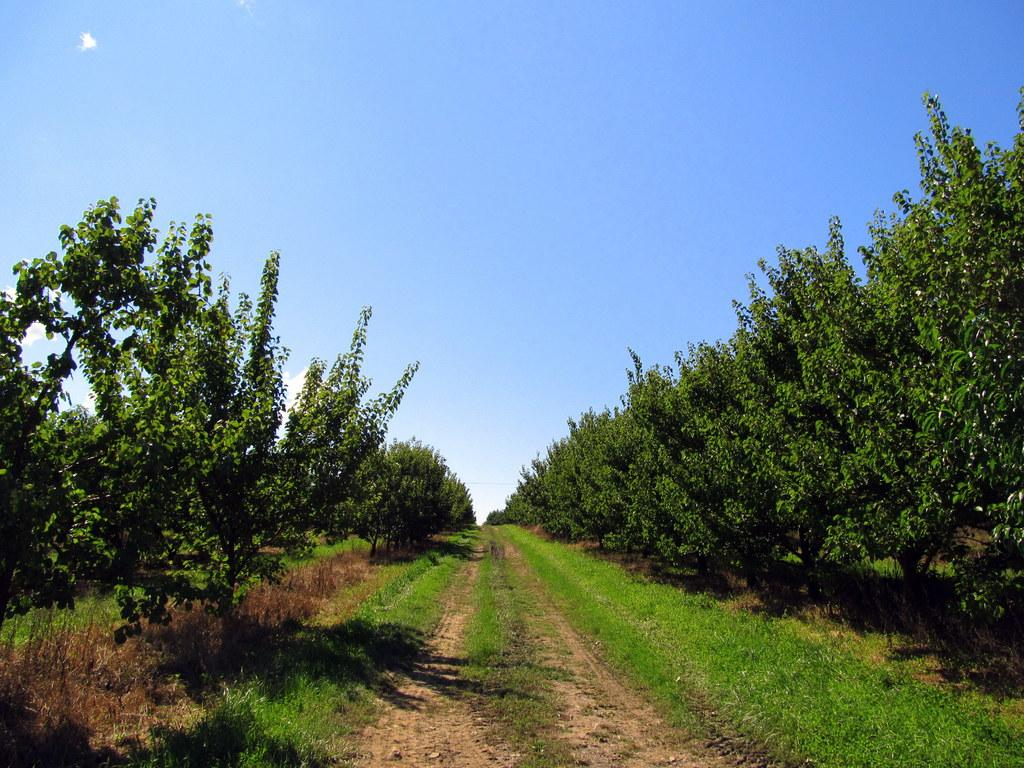What type of vegetation is visible in the image? There is grass in the image. What other natural elements can be seen in the image? There are trees in the image. What is visible at the top of the image? The sky is visible at the top of the image. Can you see any quicksand in the image? There is no quicksand present in the image. What type of house is visible in the image? There is no house visible in the image. 